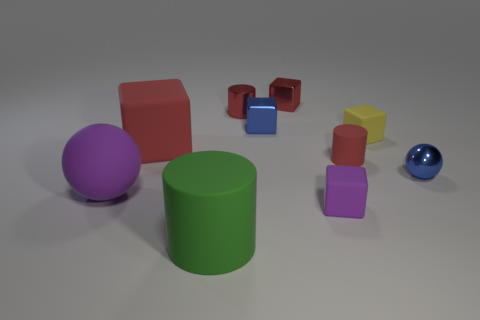Subtract 1 blocks. How many blocks are left? 4 Subtract all purple blocks. How many blocks are left? 4 Subtract all small red metallic cubes. How many cubes are left? 4 Subtract all brown cubes. Subtract all brown cylinders. How many cubes are left? 5 Subtract all spheres. How many objects are left? 8 Add 5 red metal cylinders. How many red metal cylinders are left? 6 Add 10 purple matte cylinders. How many purple matte cylinders exist? 10 Subtract 0 yellow spheres. How many objects are left? 10 Subtract all purple matte balls. Subtract all blocks. How many objects are left? 4 